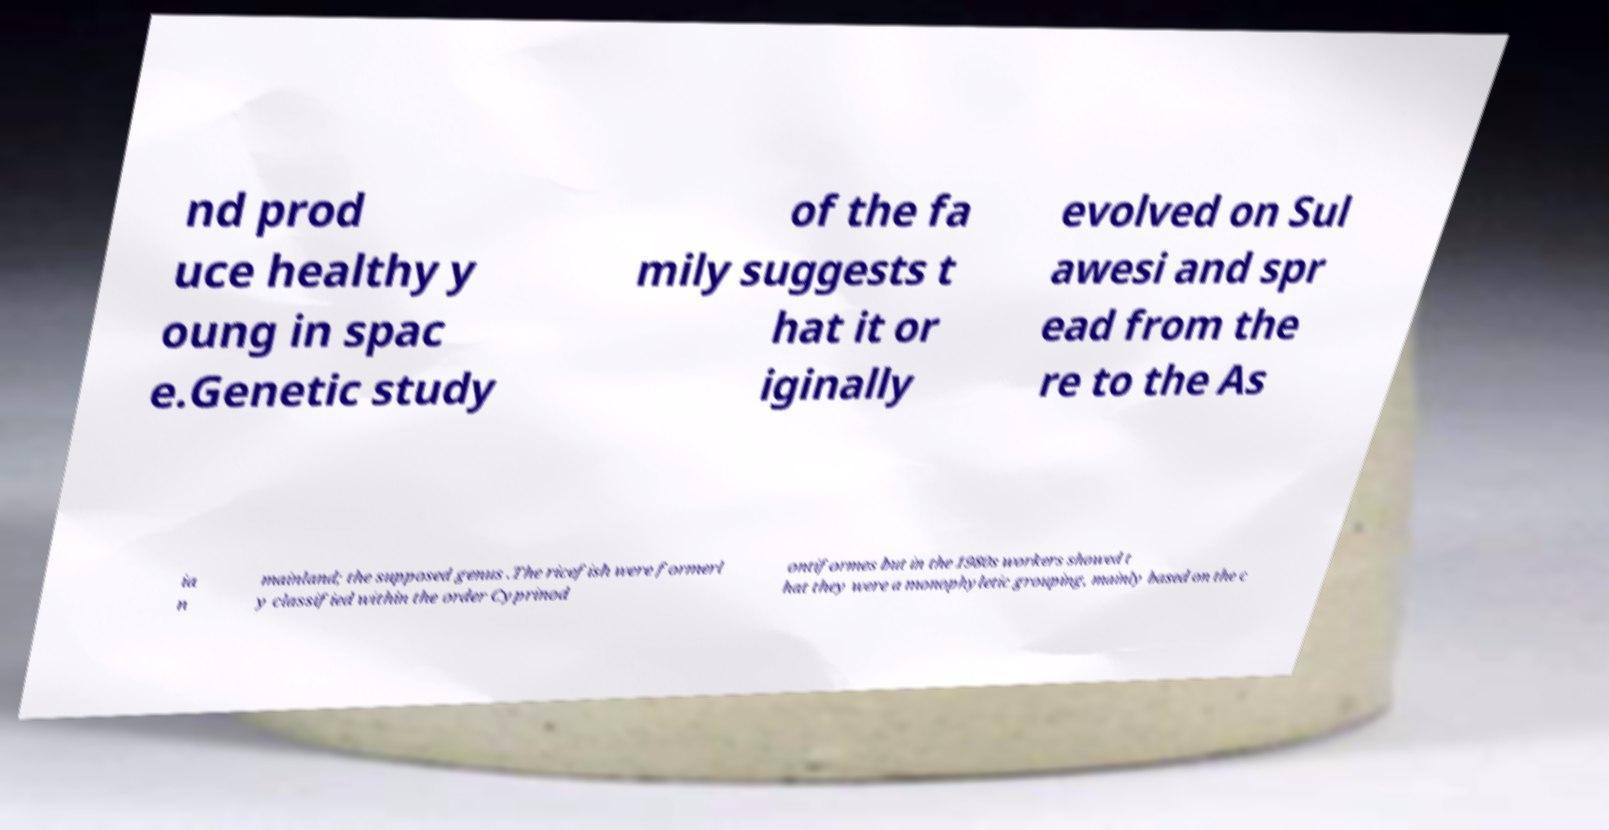Please identify and transcribe the text found in this image. nd prod uce healthy y oung in spac e.Genetic study of the fa mily suggests t hat it or iginally evolved on Sul awesi and spr ead from the re to the As ia n mainland; the supposed genus .The ricefish were formerl y classified within the order Cyprinod ontiformes but in the 1980s workers showed t hat they were a monophyletic grouping, mainly based on the c 